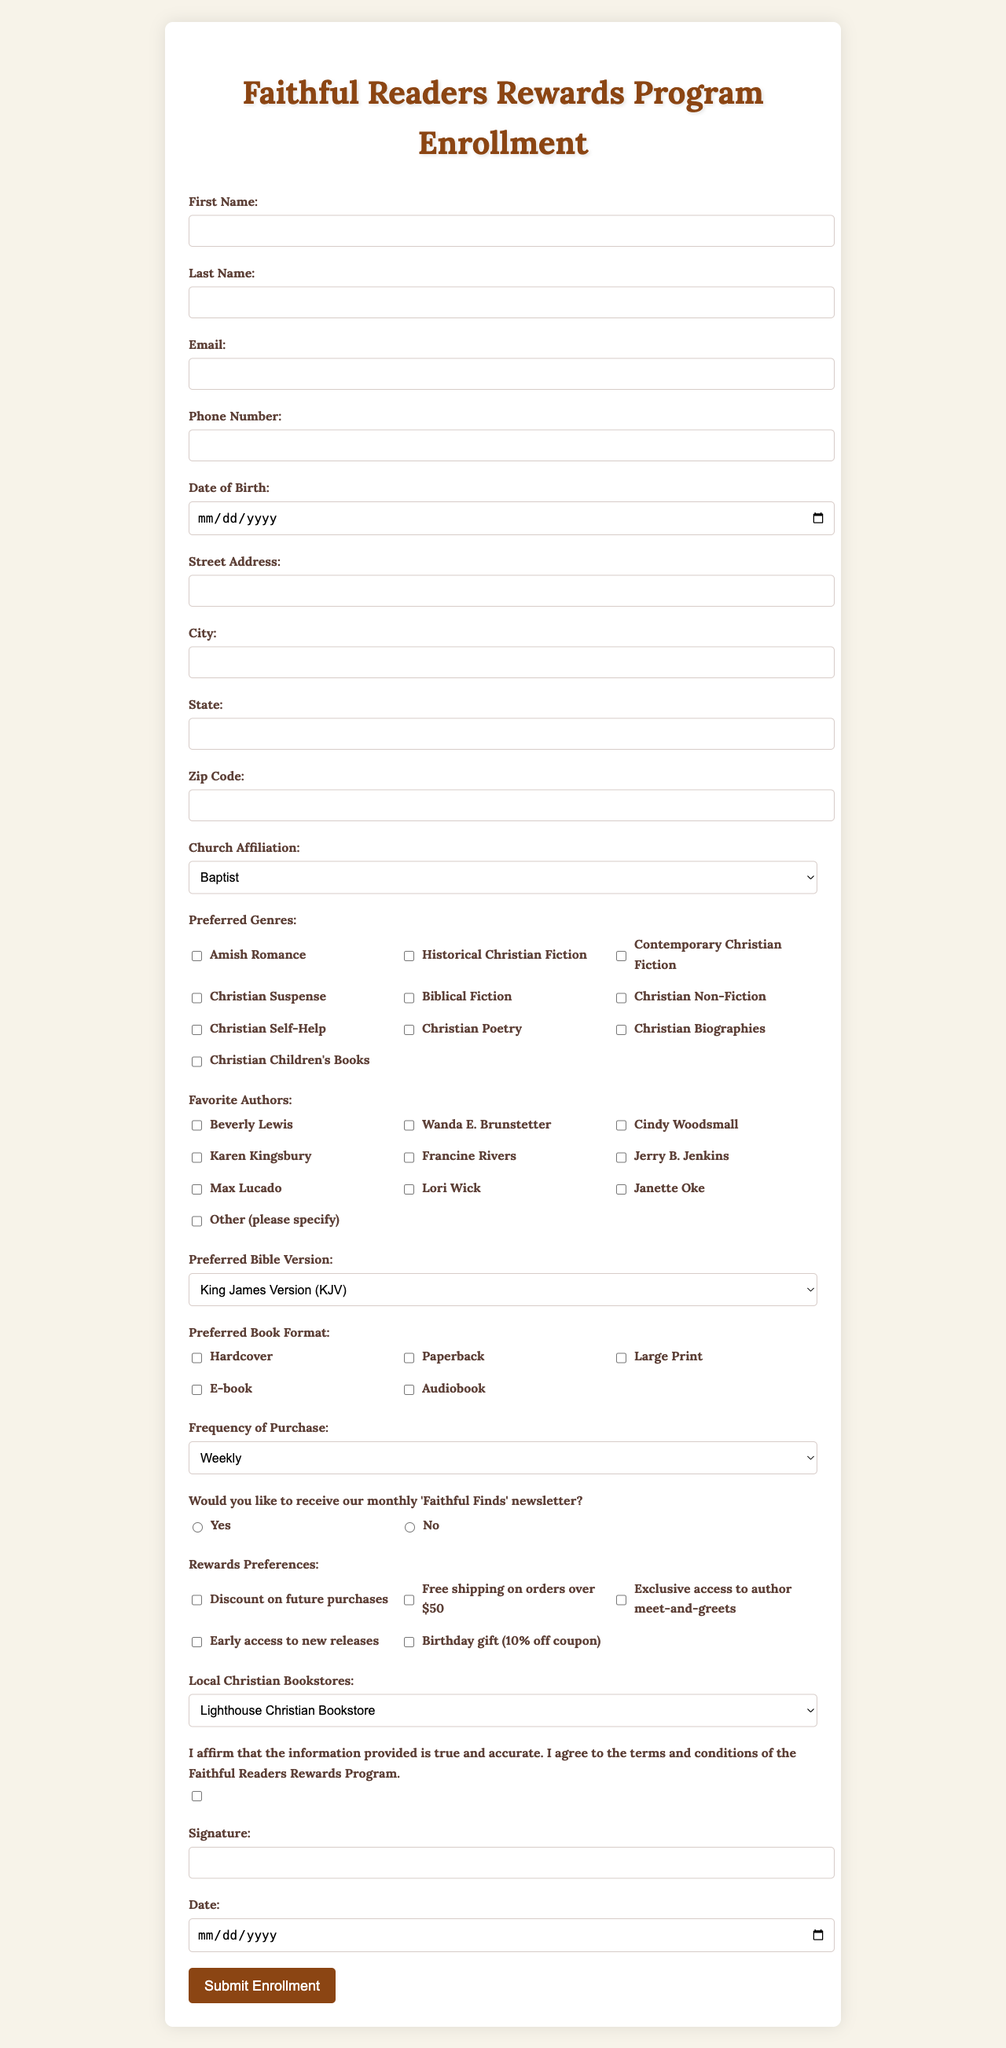what is the title of the form? The title of the form is indicated at the top of the document, which is the name of the enrollment program.
Answer: Faithful Readers Rewards Program Enrollment which genres are preferred in this enrollment form? The preferred genres are listed in a section of the form for respondents to select their favorites.
Answer: Amish Romance, Historical Christian Fiction, Contemporary Christian Fiction, Christian Suspense, Biblical Fiction, Christian Non-Fiction, Christian Self-Help, Christian Poetry, Christian Biographies, Christian Children's Books how many options are available for church affiliation? The number of options for church affiliation can be counted from the list provided in the document.
Answer: Six what is the maximum age for signing up based on the date of birth field? The date of birth field helps determine the potential maximum age for signing up based on current assumptions of age limits; however, none is specified.
Answer: None specified which format can participants prefer for books? The form provides several options for book formats that participants can choose from in one of its sections.
Answer: Hardcover, Paperback, Large Print, E-book, Audiobook who is one of the favorite authors listed? The favorite authors are given in a specific section of the form, and any of them can be named.
Answer: Beverly Lewis what is the purpose of the 'Faithful Finds' newsletter section? The newsletter section asks participants if they would like to receive updates and information via email.
Answer: To receive newsletter what does the declaration state? The declaration at the end of the form signifies the truthfulness of the information provided and agreement to the program terms.
Answer: I affirm that the information provided is true and accurate. I agree to the terms and conditions of the Faithful Readers Rewards Program what kind of reward preference includes a birthday benefit? The document mentions several reward preferences, one of which explicitly includes a birthday benefit.
Answer: Birthday gift (10% off coupon) 